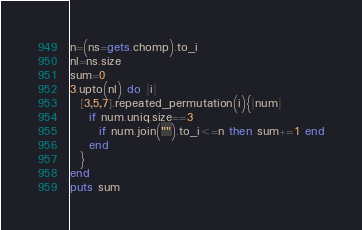Convert code to text. <code><loc_0><loc_0><loc_500><loc_500><_Ruby_>n=(ns=gets.chomp).to_i
nl=ns.size
sum=0
3.upto(nl) do |i|
  [3,5,7].repeated_permutation(i){|num|
    if num.uniq.size==3
      if num.join("").to_i<=n then sum+=1 end
    end
  }
end
puts sum
</code> 